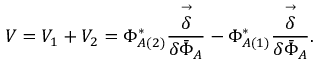Convert formula to latex. <formula><loc_0><loc_0><loc_500><loc_500>V = V _ { 1 } + V _ { 2 } = \Phi _ { A ( 2 ) } ^ { * } \frac { \stackrel { \rightarrow } { \delta } } { \delta { \bar { \Phi } } _ { A } } - \Phi _ { A ( 1 ) } ^ { * } \frac { \stackrel { \rightarrow } { \delta } } { \delta { \bar { \Phi } } _ { A } } .</formula> 